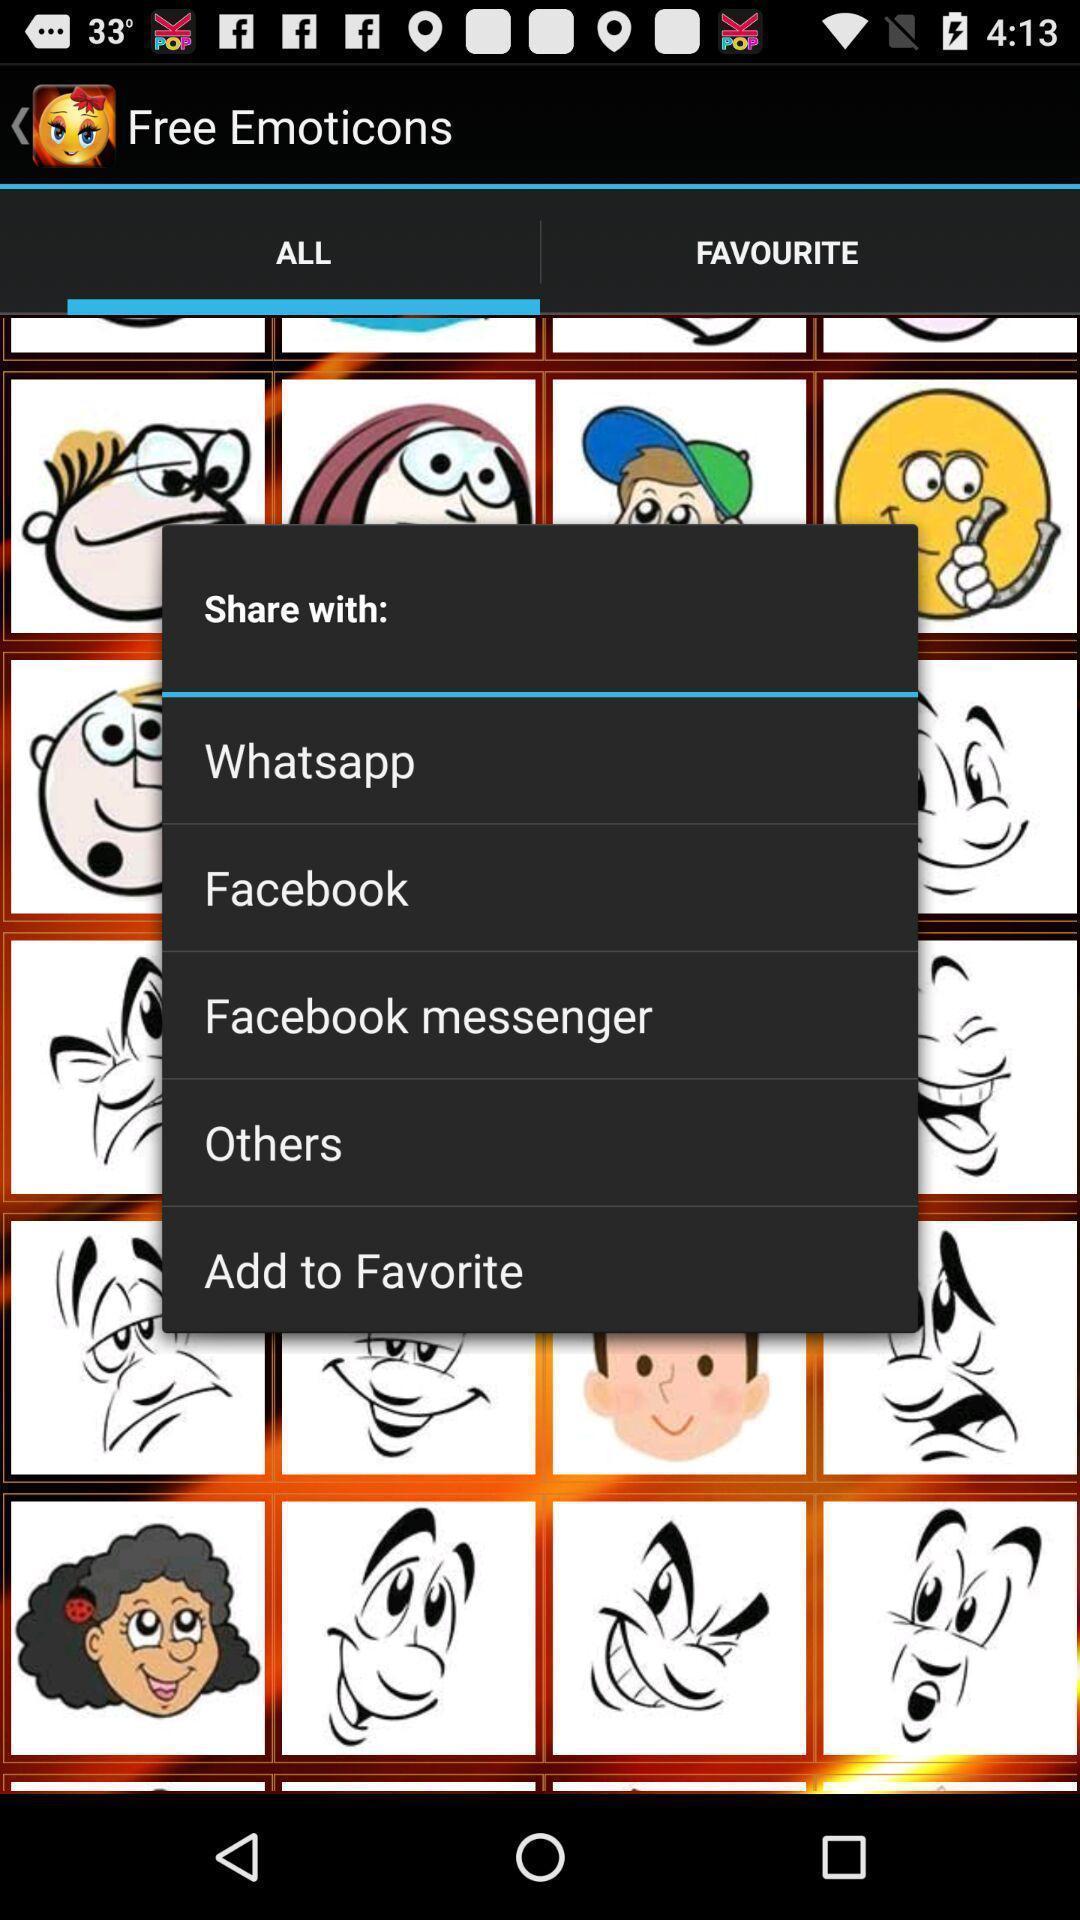Provide a detailed account of this screenshot. Popup of social media application to share the stickers. 